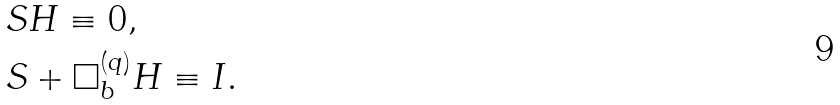<formula> <loc_0><loc_0><loc_500><loc_500>& S H \equiv 0 , \\ & S + \Box ^ { ( q ) } _ { b } H \equiv I .</formula> 